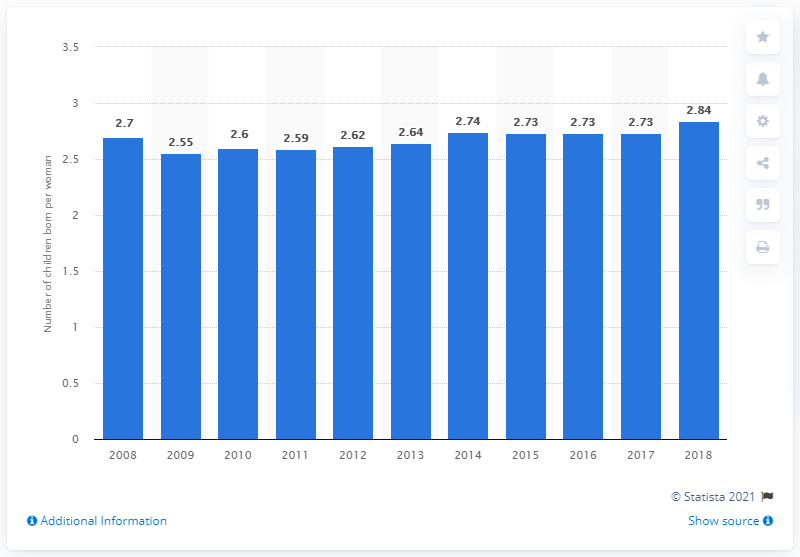Draw attention to some important aspects in this diagram. In 2018, the fertility rate in Kazakhstan was 2.84. 